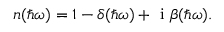<formula> <loc_0><loc_0><loc_500><loc_500>n ( \hbar { \omega } ) = 1 - \delta ( \hbar { \omega } ) + i \beta ( \hbar { \omega } ) .</formula> 